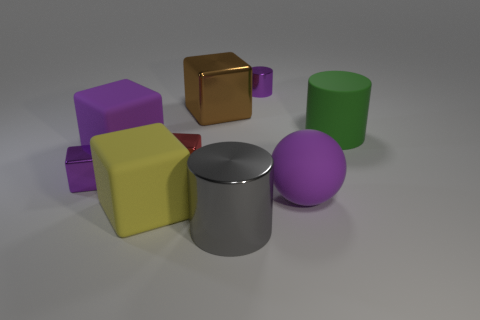What is the material of the big purple object behind the big purple object that is right of the big purple object that is left of the purple ball?
Make the answer very short. Rubber. Are there any red cylinders that have the same size as the green rubber object?
Ensure brevity in your answer.  No. There is a cylinder that is the same size as the red object; what is its material?
Give a very brief answer. Metal. What shape is the tiny purple metal thing that is left of the large yellow cube?
Provide a short and direct response. Cube. Does the big cylinder that is to the right of the big gray metal thing have the same material as the large thing left of the large yellow cube?
Provide a succinct answer. Yes. What number of green objects are the same shape as the large yellow rubber object?
Give a very brief answer. 0. There is a tiny cylinder that is the same color as the sphere; what material is it?
Make the answer very short. Metal. What number of objects are either large cubes or purple shiny objects to the right of the brown metallic cube?
Your answer should be compact. 4. What is the red block made of?
Offer a terse response. Metal. What is the material of the purple object that is the same shape as the big gray shiny object?
Your response must be concise. Metal. 